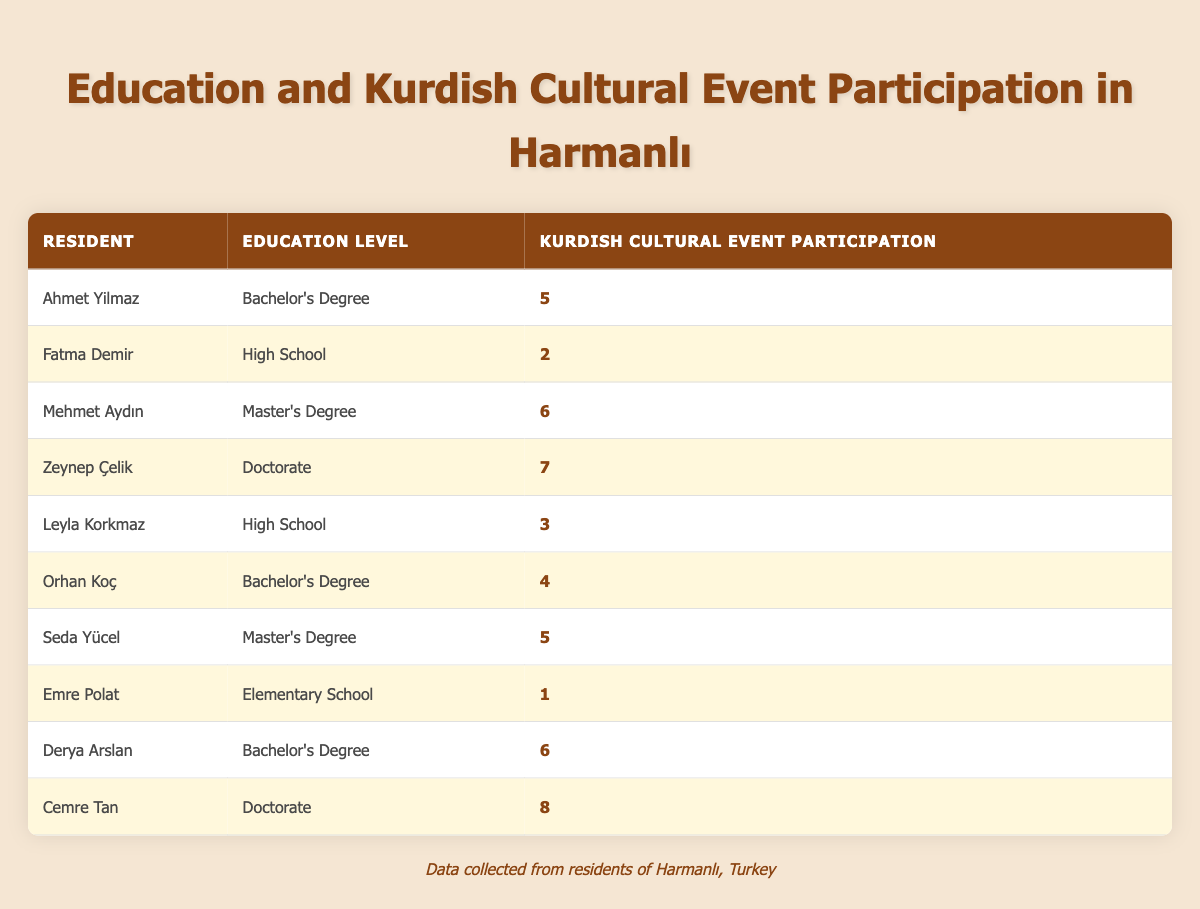What is the highest level of education among the residents? By examining the "Education Level" column, we find the highest degree listed is "Doctorate," seen in two residents: Zeynep Çelik and Cemre Tan.
Answer: Doctorate What is the participation level of Emre Polat in Kurdish cultural events? The table indicates that Emre Polat has a participation level of 1 in Kurdish cultural events.
Answer: 1 How many residents with a Bachelor's Degree participated in cultural events? The table shows three residents: Ahmet Yilmaz, Orhan Koç, and Derya Arslan, all listed with a Bachelor's Degree.
Answer: 3 What is the average participation level for those with a Master's Degree? The participation levels for Seda Yücel and Mehmet Aydın (6 and 5 respectively) sum up to 11. With 2 residents, the average is 11 divided by 2, which equals 5.5.
Answer: 5.5 Is it true that all residents with a Doctorate degree participated in more than 6 events? Checking the participation levels for Zeynep Çelik (7) and Cemre Tan (8), both exceeded 6 events, thus confirming the statement is true.
Answer: Yes What is the difference in participation levels between the highest and lowest participant in the table? Cemre Tan has the highest participation (8) while Emre Polat has the lowest (1). The difference is 8 minus 1, resulting in 7.
Answer: 7 What percentage of residents with a High School education participated in 4 or more events? Out of the two residents (Fatma Demir and Leyla Korkmaz), only Leyla Korkmaz participated in 4 or more events. This gives us a percentage of 50% (1 out of 2).
Answer: 50% Which education level has the highest average participation in cultural events? The participation levels for each education level are: Bachelor's (5), High School (2.5), Master's (5.5), and Doctorate (7.5, averaging 7 for Zeynep and Cemre). The highest average comes from Doctorate holders.
Answer: Doctorate 